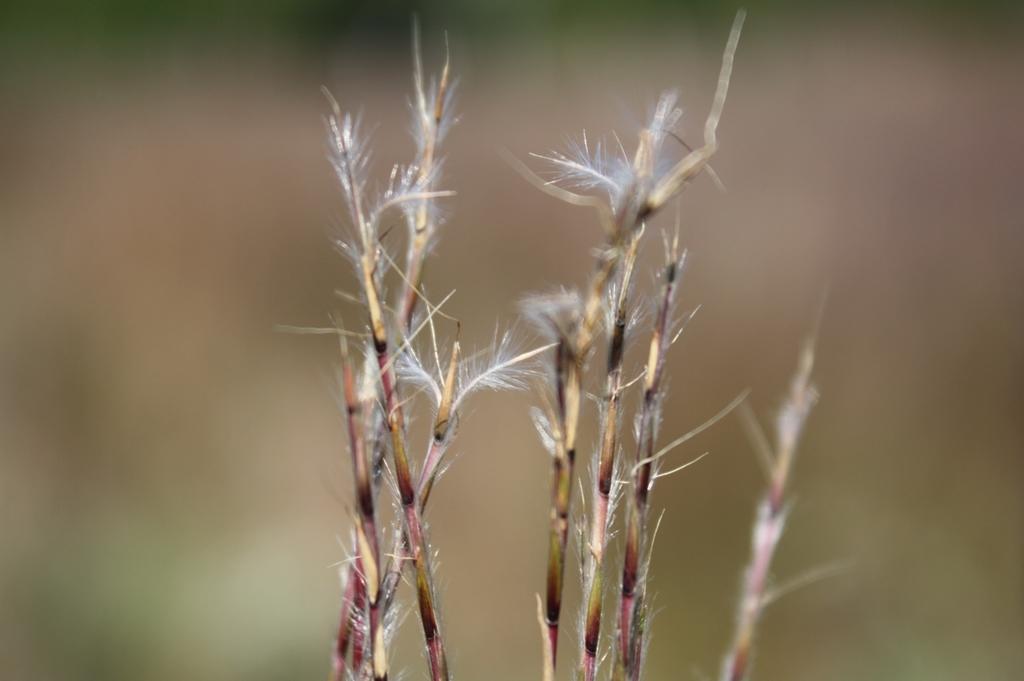Could you give a brief overview of what you see in this image? In this image we can see the bluestem grass and the background of the image is blurred. 